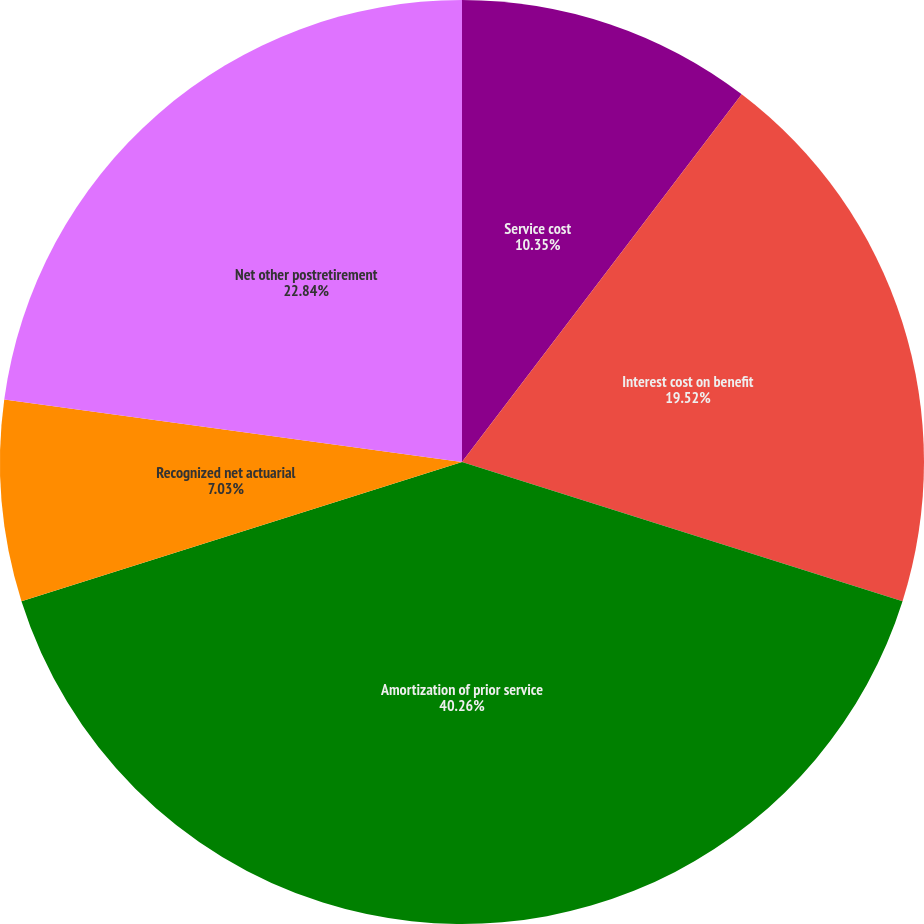Convert chart to OTSL. <chart><loc_0><loc_0><loc_500><loc_500><pie_chart><fcel>Service cost<fcel>Interest cost on benefit<fcel>Amortization of prior service<fcel>Recognized net actuarial<fcel>Net other postretirement<nl><fcel>10.35%<fcel>19.52%<fcel>40.26%<fcel>7.03%<fcel>22.84%<nl></chart> 